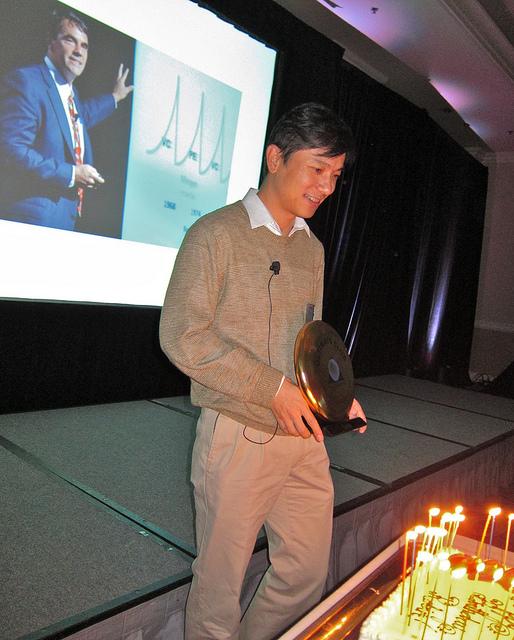What is lit on the cake?
Short answer required. Candles. How can you tell the man in the brown sweater is being honored?
Quick response, please. He has trophy. What is the man holding?
Concise answer only. Award. 